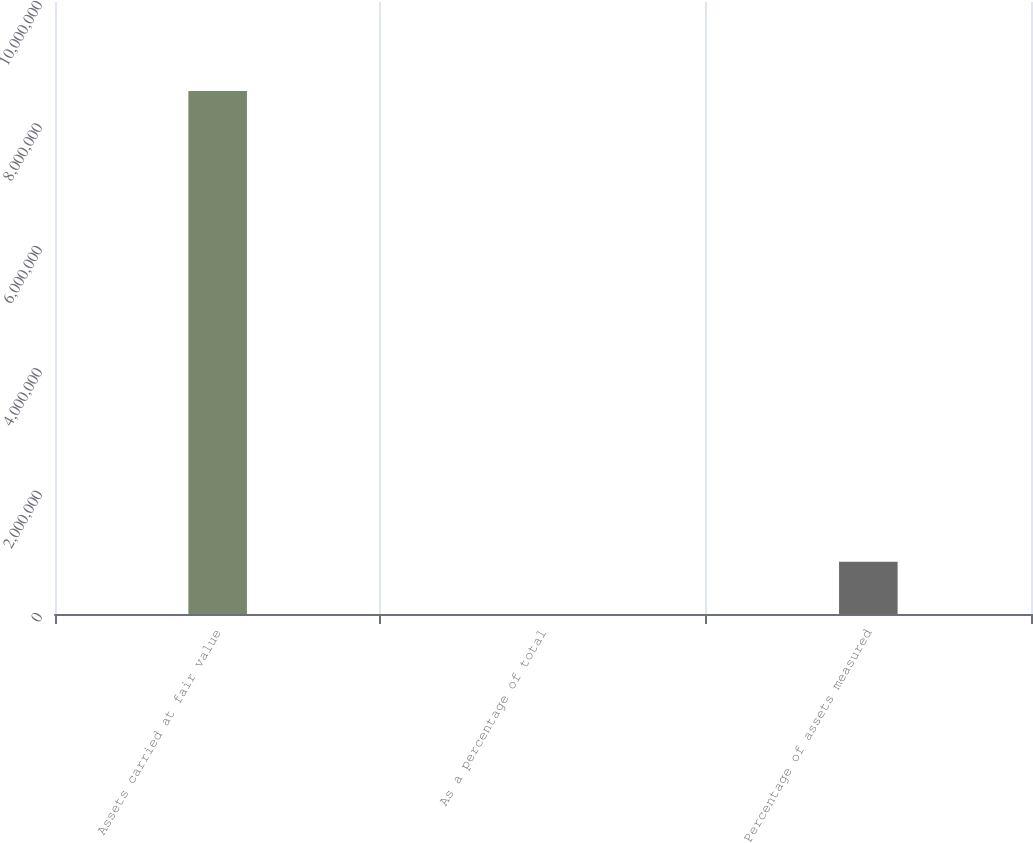Convert chart to OTSL. <chart><loc_0><loc_0><loc_500><loc_500><bar_chart><fcel>Assets carried at fair value<fcel>As a percentage of total<fcel>Percentage of assets measured<nl><fcel>8.54653e+06<fcel>48.8<fcel>854697<nl></chart> 